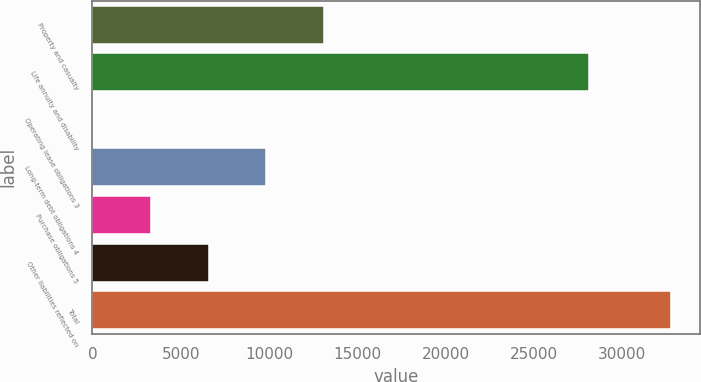<chart> <loc_0><loc_0><loc_500><loc_500><bar_chart><fcel>Property and casualty<fcel>Life annuity and disability<fcel>Operating lease obligations 3<fcel>Long-term debt obligations 4<fcel>Purchase obligations 5<fcel>Other liabilities reflected on<fcel>Total<nl><fcel>13129.2<fcel>28151<fcel>36<fcel>9855.9<fcel>3309.3<fcel>6582.6<fcel>32769<nl></chart> 